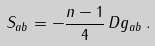<formula> <loc_0><loc_0><loc_500><loc_500>S _ { a b } = - \frac { n - 1 } { 4 } \, D g _ { a b } \, .</formula> 